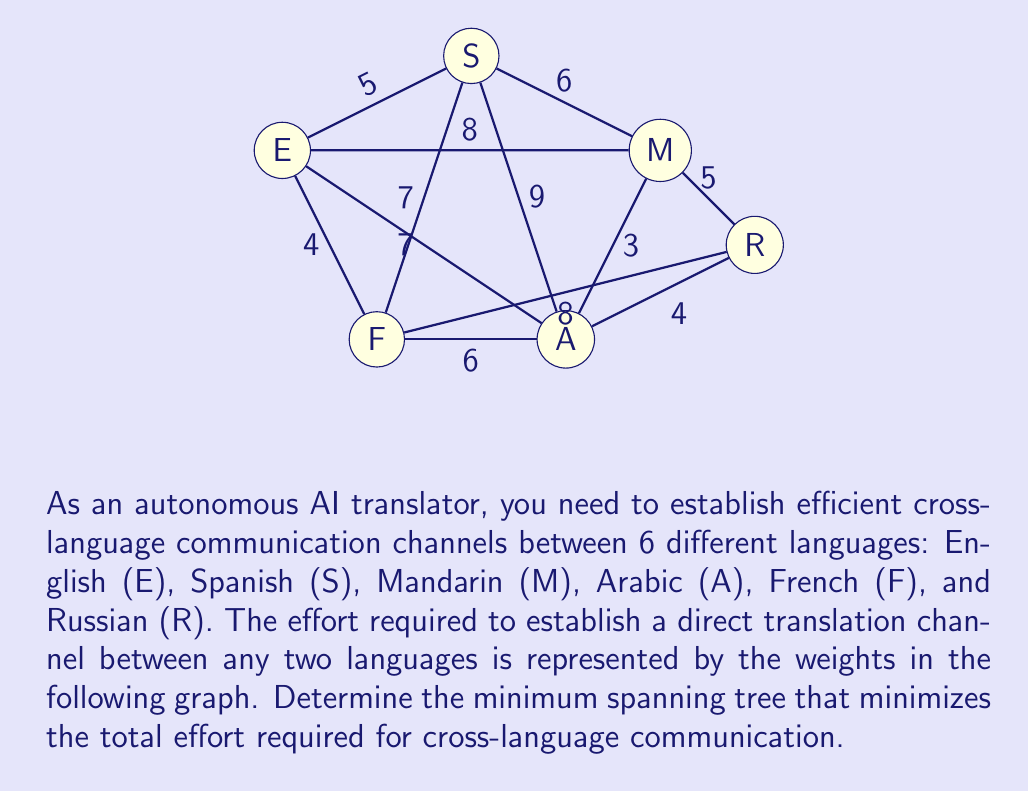Can you answer this question? To find the minimum spanning tree, we'll use Kruskal's algorithm:

1) Sort all edges by weight in ascending order:
   (M,A):3, (E,F):4, (A,R):4, (E,S):5, (M,R):5, (S,M):6, (A,F):6, (E,A):7, (S,F):7, (E,M):8, (F,R):8, (S,A):9

2) Start with an empty graph and add edges in this order, skipping any that would create a cycle:

   a) (M,A):3 - Add
   b) (E,F):4 - Add
   c) (A,R):4 - Add
   d) (E,S):5 - Add
   e) (M,R):5 - Skip (would create cycle)
   f) (S,M):6 - Add (completes the tree)

3) The resulting minimum spanning tree has 5 edges (n-1 where n is the number of nodes):
   (M,A), (E,F), (A,R), (E,S), (S,M)

4) The total weight (effort) of this minimum spanning tree is:
   $$3 + 4 + 4 + 5 + 6 = 22$$

This minimum spanning tree allows efficient translation between all languages with the least total effort.
Answer: Edges: (M,A), (E,F), (A,R), (E,S), (S,M); Total weight: 22 